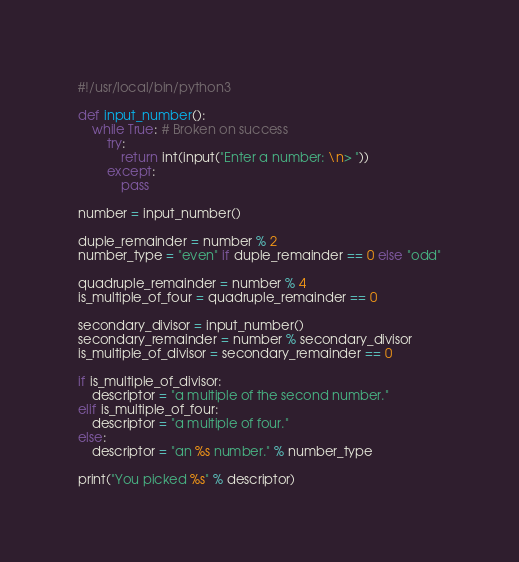Convert code to text. <code><loc_0><loc_0><loc_500><loc_500><_Python_>#!/usr/local/bin/python3

def input_number():
    while True: # Broken on success
        try:
            return int(input("Enter a number: \n> ")) 
        except:
            pass

number = input_number()

duple_remainder = number % 2
number_type = "even" if duple_remainder == 0 else "odd"

quadruple_remainder = number % 4
is_multiple_of_four = quadruple_remainder == 0

secondary_divisor = input_number() 
secondary_remainder = number % secondary_divisor
is_multiple_of_divisor = secondary_remainder == 0

if is_multiple_of_divisor:
    descriptor = "a multiple of the second number."
elif is_multiple_of_four:
    descriptor = "a multiple of four."
else:
    descriptor = "an %s number." % number_type

print("You picked %s" % descriptor)
</code> 